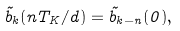<formula> <loc_0><loc_0><loc_500><loc_500>\tilde { b } _ { k } ( n T _ { K } / d ) = \tilde { b } _ { k - n } ( 0 ) ,</formula> 